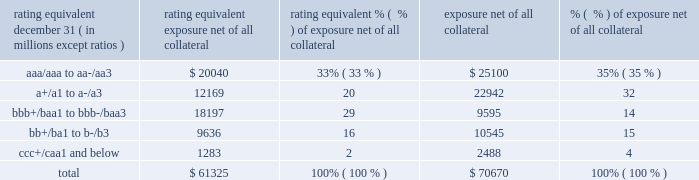Management 2019s discussion and analysis 158 jpmorgan chase & co./2012 annual report the table summarizes the ratings profile by derivative counterparty of the firm 2019s derivative receivables , including credit derivatives , net of other liquid securities collateral , for the dates indicated .
Ratings profile of derivative receivables .
As noted above , the firm uses collateral agreements to mitigate counterparty credit risk .
The percentage of the firm 2019s derivatives transactions subject to collateral agreements 2013 excluding foreign exchange spot trades , which are not typically covered by collateral agreements due to their short maturity 2013 was 88% ( 88 % ) as of december 31 , 2012 , unchanged compared with december 31 , 2011 .
Credit derivatives credit derivatives are financial instruments whose value is derived from the credit risk associated with the debt of a third party issuer ( the reference entity ) and which allow one party ( the protection purchaser ) to transfer that risk to another party ( the protection seller ) when the reference entity suffers a credit event .
If no credit event has occurred , the protection seller makes no payments to the protection purchaser .
For a more detailed description of credit derivatives , see credit derivatives in note 6 on pages 218 2013227 of this annual report .
The firm uses credit derivatives for two primary purposes : first , in its capacity as a market-maker ; and second , as an end-user , to manage the firm 2019s own credit risk associated with various exposures .
Included in end-user activities are credit derivatives used to mitigate the credit risk associated with traditional lending activities ( loans and unfunded commitments ) and derivatives counterparty exposure in the firm 2019s wholesale businesses ( 201ccredit portfolio management 201d activities ) .
Information on credit portfolio management activities is provided in the table below .
In addition , the firm uses credit derivatives as an end-user to manage other exposures , including credit risk arising from certain afs securities and from certain securities held in the firm 2019s market making businesses .
These credit derivatives , as well as the synthetic credit portfolio , are not included in credit portfolio management activities ; for further information on these credit derivatives as well as credit derivatives used in the firm 2019s capacity as a market maker in credit derivatives , see credit derivatives in note 6 on pages 226 2013227 of this annual report. .
What percentage of derivative receivables was junk rated in 2012? 
Computations: (16 - 2)
Answer: 14.0. Management 2019s discussion and analysis 158 jpmorgan chase & co./2012 annual report the table summarizes the ratings profile by derivative counterparty of the firm 2019s derivative receivables , including credit derivatives , net of other liquid securities collateral , for the dates indicated .
Ratings profile of derivative receivables .
As noted above , the firm uses collateral agreements to mitigate counterparty credit risk .
The percentage of the firm 2019s derivatives transactions subject to collateral agreements 2013 excluding foreign exchange spot trades , which are not typically covered by collateral agreements due to their short maturity 2013 was 88% ( 88 % ) as of december 31 , 2012 , unchanged compared with december 31 , 2011 .
Credit derivatives credit derivatives are financial instruments whose value is derived from the credit risk associated with the debt of a third party issuer ( the reference entity ) and which allow one party ( the protection purchaser ) to transfer that risk to another party ( the protection seller ) when the reference entity suffers a credit event .
If no credit event has occurred , the protection seller makes no payments to the protection purchaser .
For a more detailed description of credit derivatives , see credit derivatives in note 6 on pages 218 2013227 of this annual report .
The firm uses credit derivatives for two primary purposes : first , in its capacity as a market-maker ; and second , as an end-user , to manage the firm 2019s own credit risk associated with various exposures .
Included in end-user activities are credit derivatives used to mitigate the credit risk associated with traditional lending activities ( loans and unfunded commitments ) and derivatives counterparty exposure in the firm 2019s wholesale businesses ( 201ccredit portfolio management 201d activities ) .
Information on credit portfolio management activities is provided in the table below .
In addition , the firm uses credit derivatives as an end-user to manage other exposures , including credit risk arising from certain afs securities and from certain securities held in the firm 2019s market making businesses .
These credit derivatives , as well as the synthetic credit portfolio , are not included in credit portfolio management activities ; for further information on these credit derivatives as well as credit derivatives used in the firm 2019s capacity as a market maker in credit derivatives , see credit derivatives in note 6 on pages 226 2013227 of this annual report. .
What was the percent of the derivative receivables total exposure net of all collateral that was a+/a1 to a-/a3? 
Computations: (12169 / 61325)
Answer: 0.19843. 